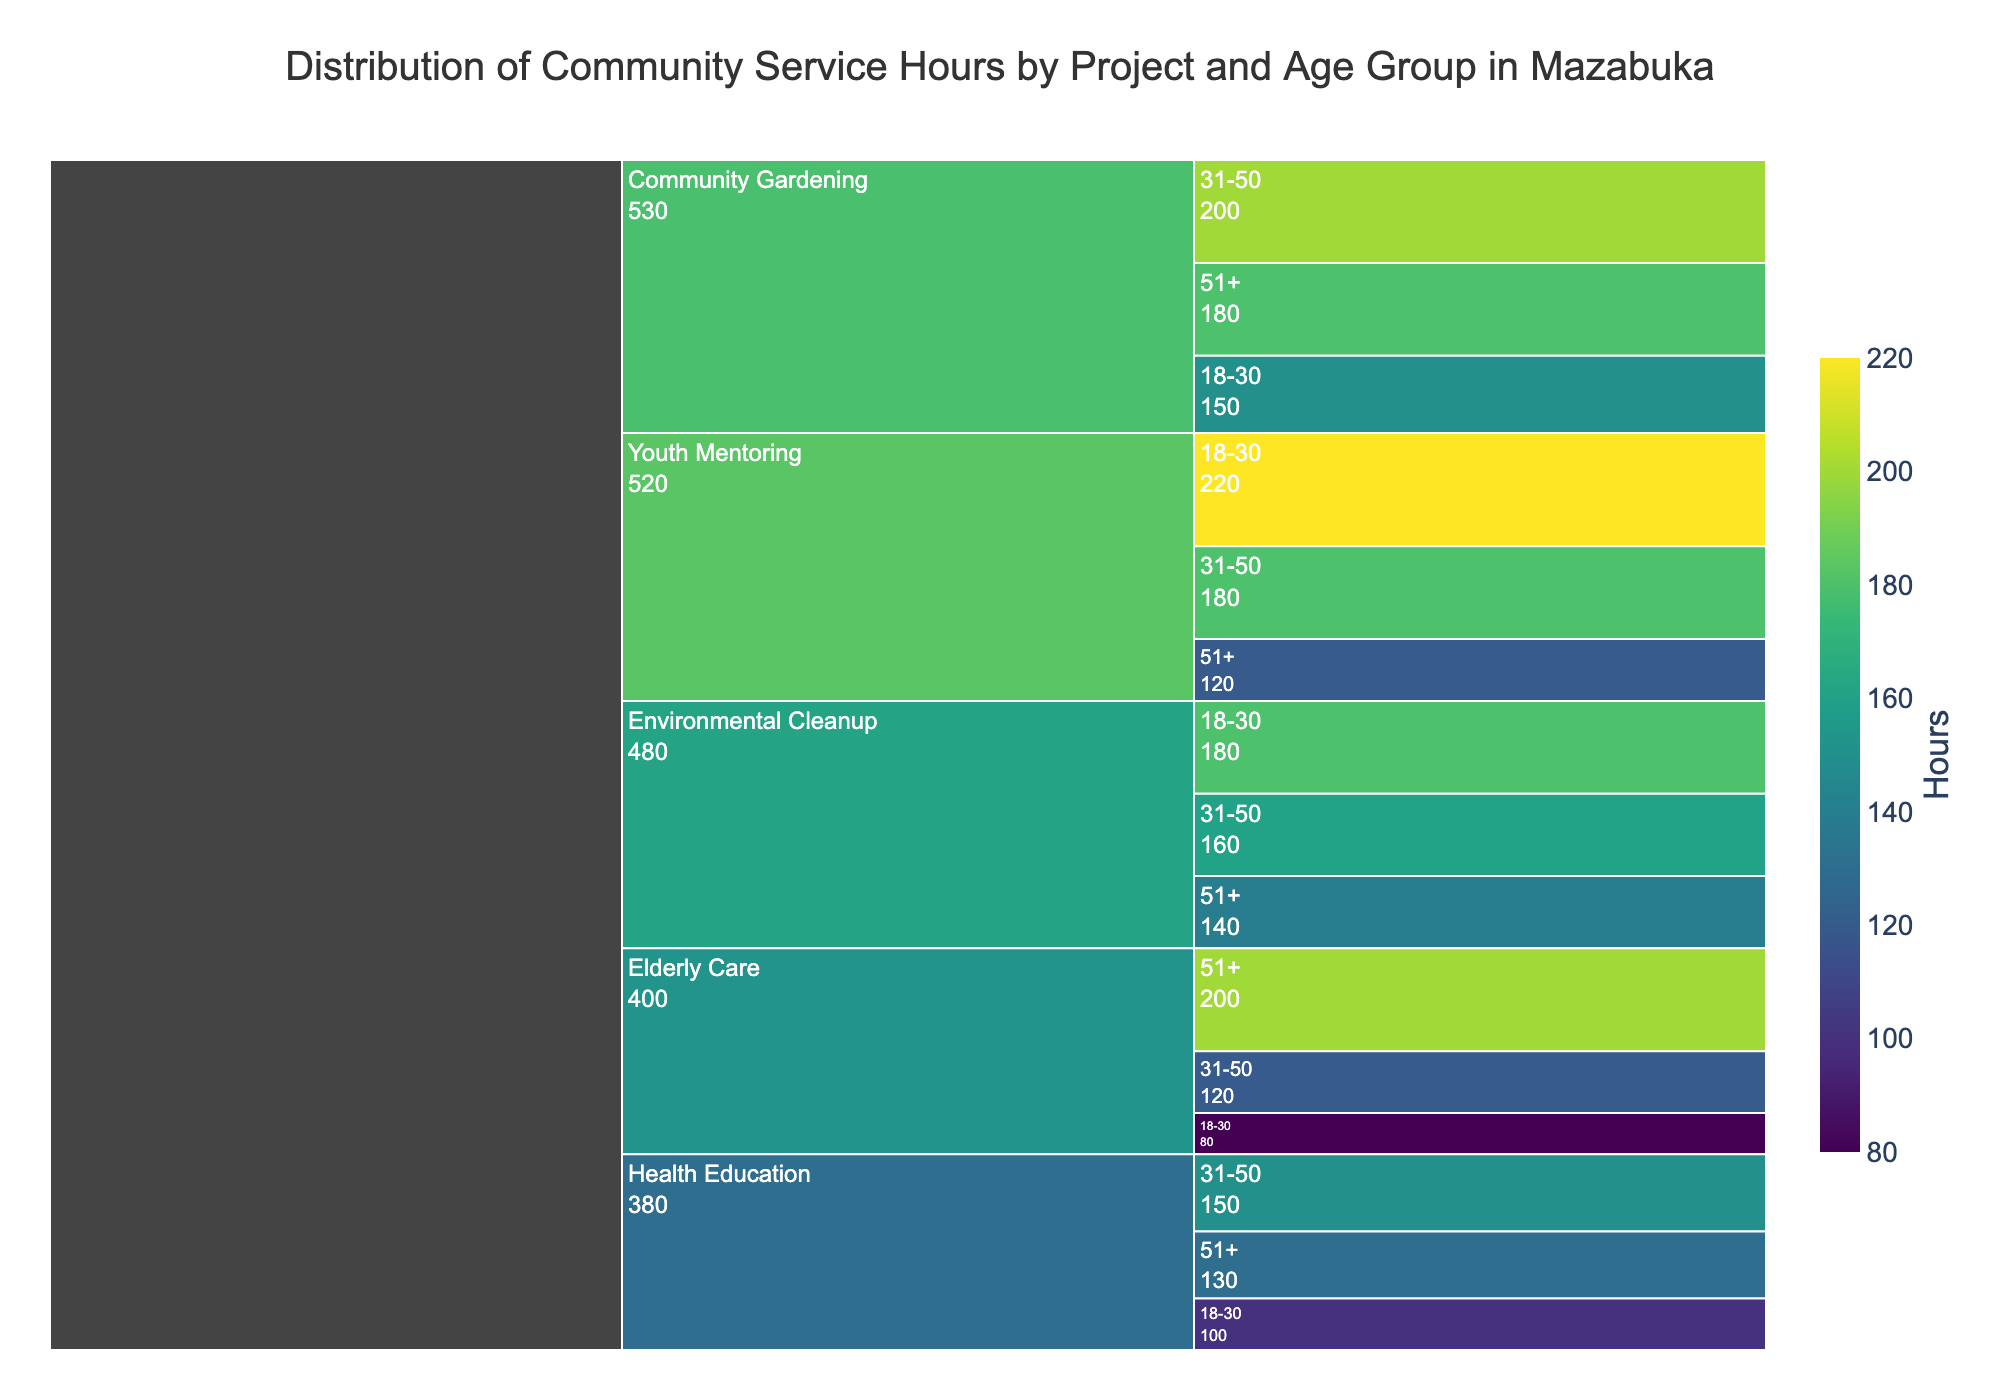Which project had the smallest contribution from people aged 18-30? Compare the "18-30" segments for each project: Community Gardening (150), Youth Mentoring (220), Health Education (100), Environmental Cleanup (180), Elderly Care (80). The smallest contribution is for Elderly Care with 80 hours.
Answer: Elderly Care What is the combined total of hours for Community Gardening and Elderly Care projects for the 51+ age group? For the 51+ age group, sum the hours from "Community Gardening" (180) and "Elderly Care" (200). Total is 180 + 200 = 380.
Answer: 380 Which project has a similar number of hours volunteered by people over 51 and people between 18-30? Compare the hours for 51+ and 18-30 groups in each project: "Health Education" has 51+ (130) and 18-30 (100), Environmental Cleanup has 51+ (140) and 18-30 (180), Community Gardening has 51+ (180) and 18-30 (150), "Youth Mentoring" has 51+ (120) and 18-30 (220), "Elderly Care" has 51+ (200) and 18-30 (80). None have close numbers, but Environmental Cleanup is the closest.
Answer: Environmental Cleanup What is the difference in hours volunteered for Youth Mentoring between 18-30 and 51+ age groups? Subtract the hours of 51+ (120) from 18-30 (220) for Youth Mentoring: 220 - 120 = 100.
Answer: 100 